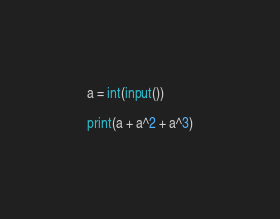Convert code to text. <code><loc_0><loc_0><loc_500><loc_500><_Python_>a = int(input())

print(a + a^2 + a^3)</code> 